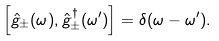<formula> <loc_0><loc_0><loc_500><loc_500>\left [ \hat { g } _ { \pm } ( \omega ) , \hat { g } ^ { \dagger } _ { \pm } ( \omega ^ { \prime } ) \right ] = \delta ( \omega - \omega ^ { \prime } ) .</formula> 